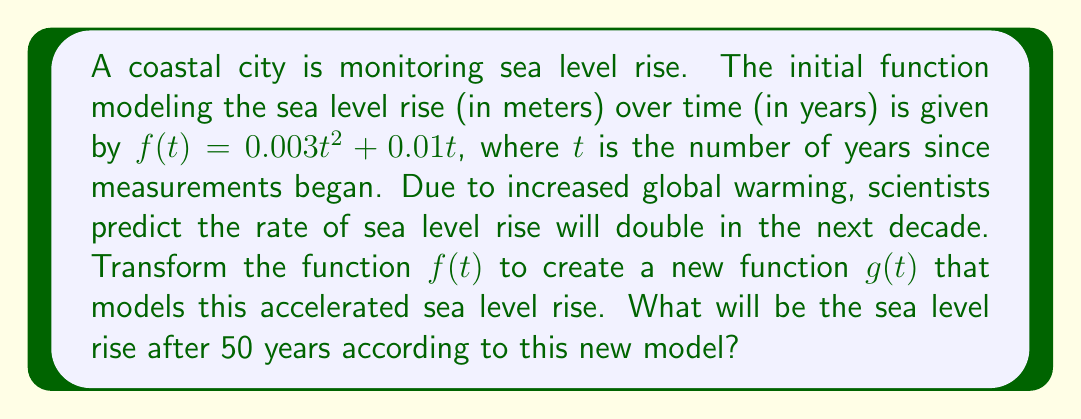Show me your answer to this math problem. 1) The original function is $f(t) = 0.003t^2 + 0.01t$

2) To double the rate of sea level rise, we need to multiply the function by 2:
   $g(t) = 2f(t) = 2(0.003t^2 + 0.01t)$

3) Simplify the new function:
   $g(t) = 0.006t^2 + 0.02t$

4) To find the sea level rise after 50 years, we need to evaluate $g(50)$:
   $g(50) = 0.006(50)^2 + 0.02(50)$

5) Calculate:
   $g(50) = 0.006(2500) + 1$
   $g(50) = 15 + 1 = 16$

Therefore, the sea level rise after 50 years according to the new model will be 16 meters.
Answer: 16 meters 